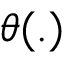Convert formula to latex. <formula><loc_0><loc_0><loc_500><loc_500>\theta ( . )</formula> 